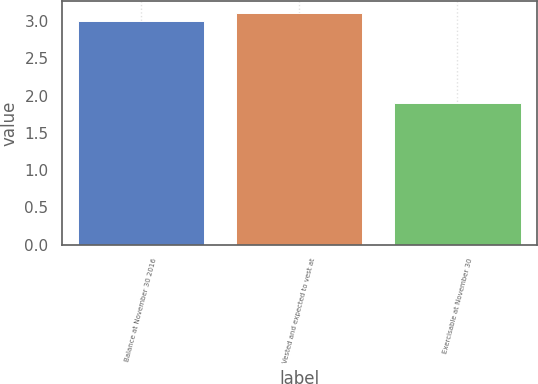<chart> <loc_0><loc_0><loc_500><loc_500><bar_chart><fcel>Balance at November 30 2016<fcel>Vested and expected to vest at<fcel>Exercisable at November 30<nl><fcel>3<fcel>3.11<fcel>1.9<nl></chart> 